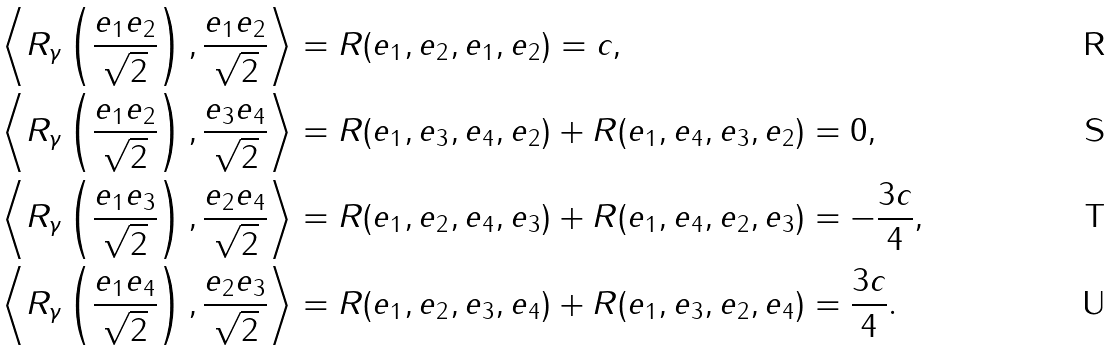Convert formula to latex. <formula><loc_0><loc_0><loc_500><loc_500>\left \langle R _ { \gamma } \left ( \frac { e _ { 1 } e _ { 2 } } { \sqrt { 2 } } \right ) , \frac { e _ { 1 } e _ { 2 } } { \sqrt { 2 } } \right \rangle & = R ( e _ { 1 } , e _ { 2 } , e _ { 1 } , e _ { 2 } ) = c , \\ \left \langle R _ { \gamma } \left ( \frac { e _ { 1 } e _ { 2 } } { \sqrt { 2 } } \right ) , \frac { e _ { 3 } e _ { 4 } } { \sqrt { 2 } } \right \rangle & = R ( e _ { 1 } , e _ { 3 } , e _ { 4 } , e _ { 2 } ) + R ( e _ { 1 } , e _ { 4 } , e _ { 3 } , e _ { 2 } ) = 0 , \\ \left \langle R _ { \gamma } \left ( \frac { e _ { 1 } e _ { 3 } } { \sqrt { 2 } } \right ) , \frac { e _ { 2 } e _ { 4 } } { \sqrt { 2 } } \right \rangle & = R ( e _ { 1 } , e _ { 2 } , e _ { 4 } , e _ { 3 } ) + R ( e _ { 1 } , e _ { 4 } , e _ { 2 } , e _ { 3 } ) = - \frac { 3 c } { 4 } , \\ \left \langle R _ { \gamma } \left ( \frac { e _ { 1 } e _ { 4 } } { \sqrt { 2 } } \right ) , \frac { e _ { 2 } e _ { 3 } } { \sqrt { 2 } } \right \rangle & = R ( e _ { 1 } , e _ { 2 } , e _ { 3 } , e _ { 4 } ) + R ( e _ { 1 } , e _ { 3 } , e _ { 2 } , e _ { 4 } ) = \frac { 3 c } { 4 } .</formula> 